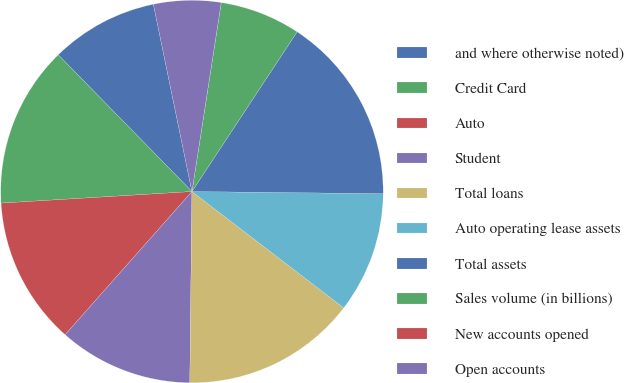Convert chart. <chart><loc_0><loc_0><loc_500><loc_500><pie_chart><fcel>and where otherwise noted)<fcel>Credit Card<fcel>Auto<fcel>Student<fcel>Total loans<fcel>Auto operating lease assets<fcel>Total assets<fcel>Sales volume (in billions)<fcel>New accounts opened<fcel>Open accounts<nl><fcel>9.09%<fcel>13.64%<fcel>12.5%<fcel>11.36%<fcel>14.77%<fcel>10.23%<fcel>15.91%<fcel>6.82%<fcel>0.0%<fcel>5.68%<nl></chart> 